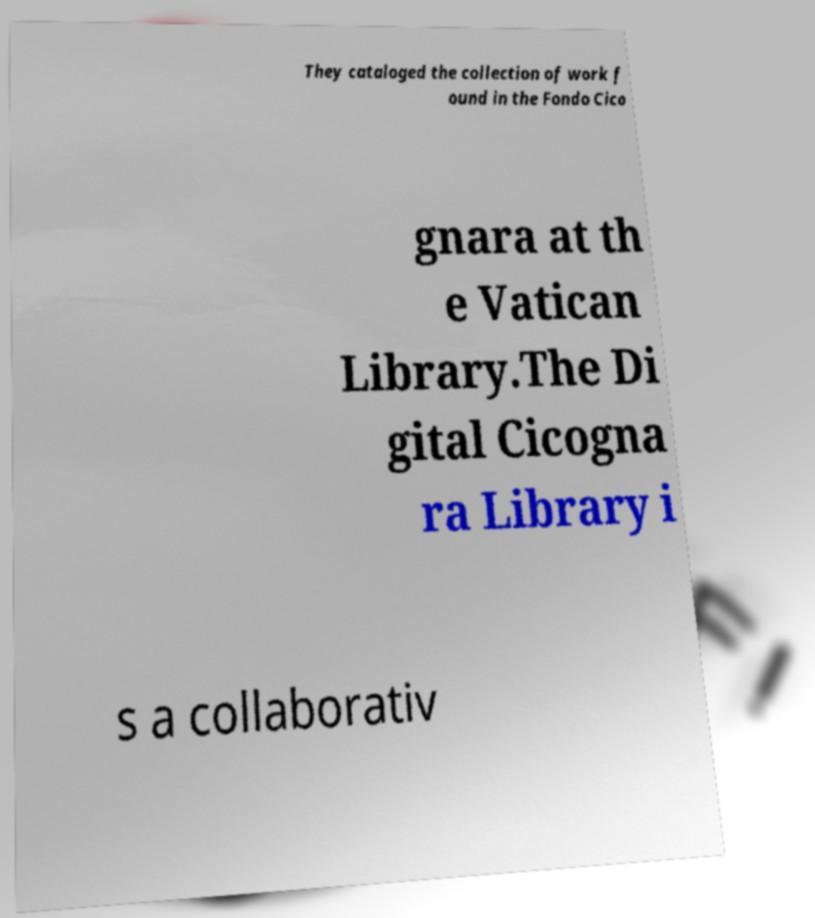What messages or text are displayed in this image? I need them in a readable, typed format. They cataloged the collection of work f ound in the Fondo Cico gnara at th e Vatican Library.The Di gital Cicogna ra Library i s a collaborativ 